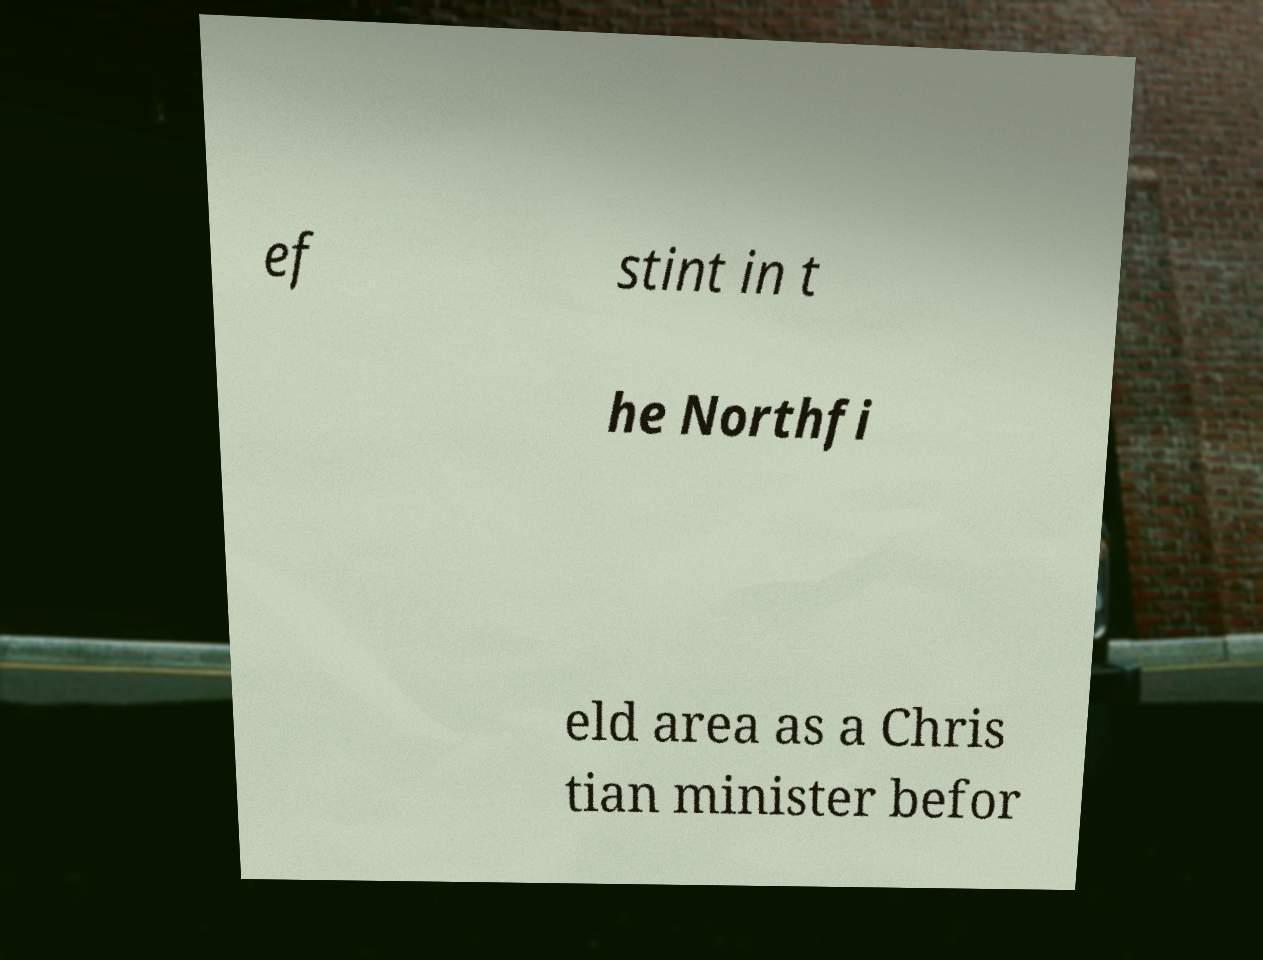I need the written content from this picture converted into text. Can you do that? ef stint in t he Northfi eld area as a Chris tian minister befor 